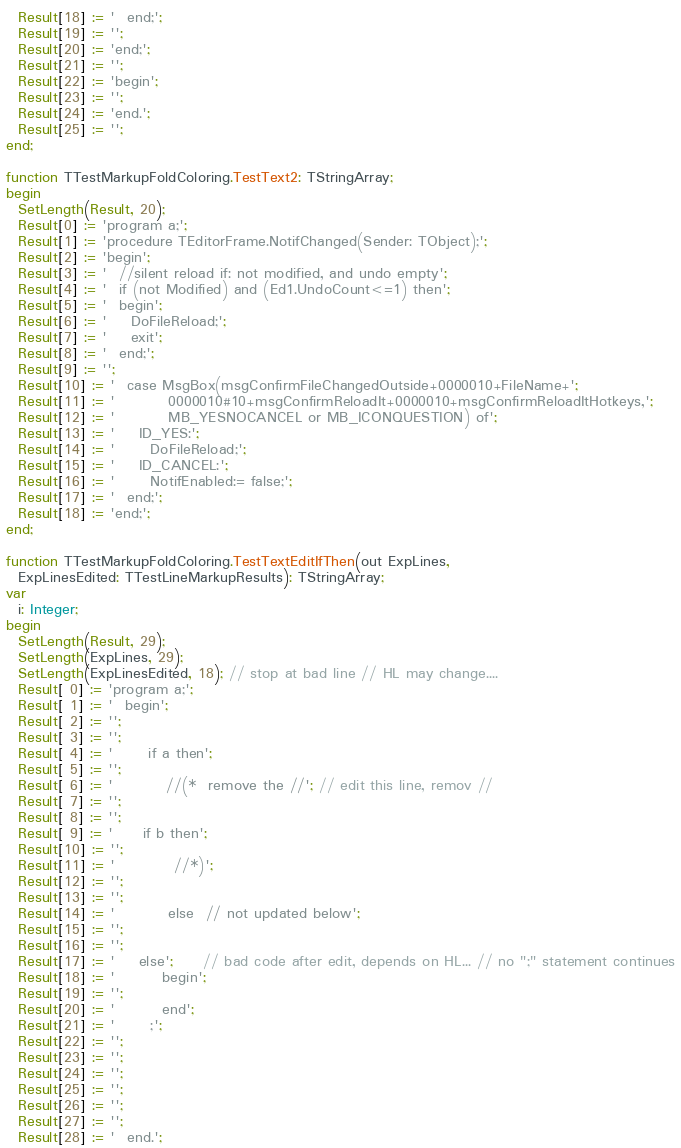Convert code to text. <code><loc_0><loc_0><loc_500><loc_500><_Pascal_>  Result[18] := '  end;';
  Result[19] := '';
  Result[20] := 'end;';
  Result[21] := '';
  Result[22] := 'begin';
  Result[23] := '';
  Result[24] := 'end.';
  Result[25] := '';
end;

function TTestMarkupFoldColoring.TestText2: TStringArray;
begin
  SetLength(Result, 20);
  Result[0] := 'program a;';
  Result[1] := 'procedure TEditorFrame.NotifChanged(Sender: TObject);';
  Result[2] := 'begin';
  Result[3] := '  //silent reload if: not modified, and undo empty';
  Result[4] := '  if (not Modified) and (Ed1.UndoCount<=1) then';
  Result[5] := '  begin';
  Result[6] := '    DoFileReload;';
  Result[7] := '    exit';
  Result[8] := '  end;';
  Result[9] := '';
  Result[10] := '  case MsgBox(msgConfirmFileChangedOutside+0000010+FileName+';
  Result[11] := '         0000010#10+msgConfirmReloadIt+0000010+msgConfirmReloadItHotkeys,';
  Result[12] := '         MB_YESNOCANCEL or MB_ICONQUESTION) of';
  Result[13] := '    ID_YES:';
  Result[14] := '      DoFileReload;';
  Result[15] := '    ID_CANCEL:';
  Result[16] := '      NotifEnabled:= false;';
  Result[17] := '  end;';
  Result[18] := 'end;';
end;

function TTestMarkupFoldColoring.TestTextEditIfThen(out ExpLines,
  ExpLinesEdited: TTestLineMarkupResults): TStringArray;
var
  i: Integer;
begin
  SetLength(Result, 29);
  SetLength(ExpLines, 29);
  SetLength(ExpLinesEdited, 18); // stop at bad line // HL may change....
  Result[ 0] := 'program a;';
  Result[ 1] := '  begin';
  Result[ 2] := '';
  Result[ 3] := '';
  Result[ 4] := '      if a then';
  Result[ 5] := '';
  Result[ 6] := '         //(*  remove the //'; // edit this line, remov //
  Result[ 7] := '';
  Result[ 8] := '';
  Result[ 9] := '     if b then';
  Result[10] := '';
  Result[11] := '          //*)';
  Result[12] := '';
  Result[13] := '';
  Result[14] := '         else  // not updated below';
  Result[15] := '';
  Result[16] := '';
  Result[17] := '    else';     // bad code after edit, depends on HL... // no ";" statement continues
  Result[18] := '        begin';
  Result[19] := '';
  Result[20] := '        end';
  Result[21] := '      ;';
  Result[22] := '';
  Result[23] := '';
  Result[24] := '';
  Result[25] := '';
  Result[26] := '';
  Result[27] := '';
  Result[28] := '  end.';
</code> 